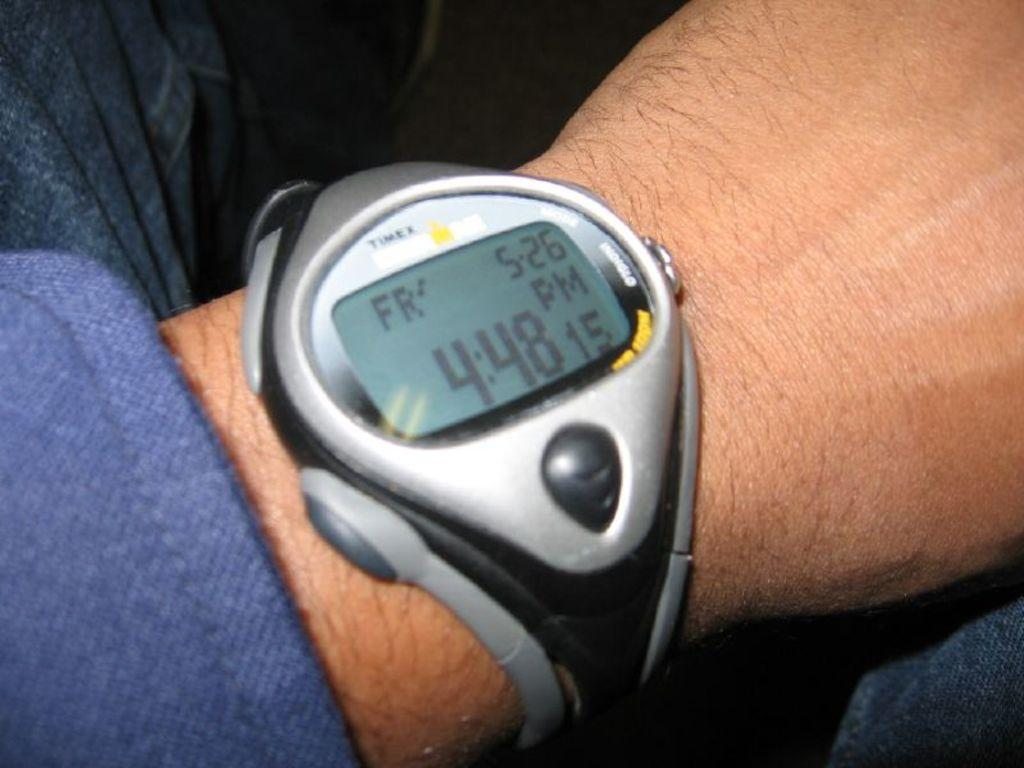<image>
Summarize the visual content of the image. Person wearing a watch that has the time at 4:48. 